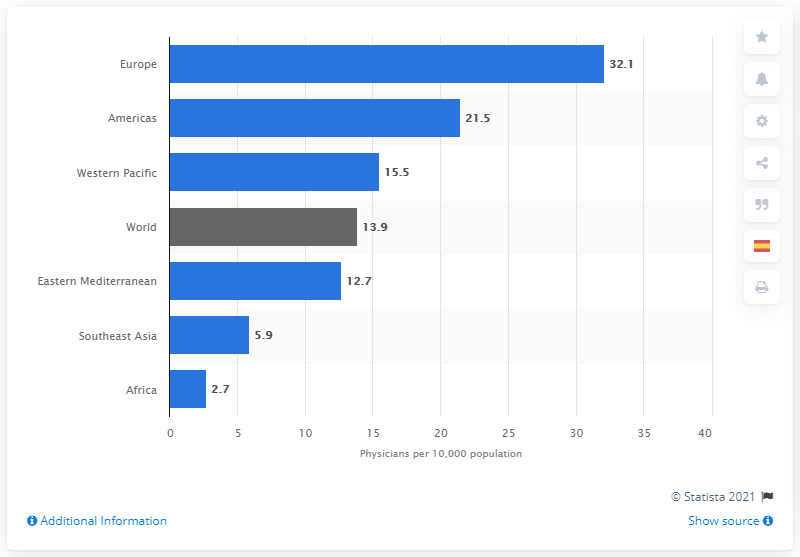Indicate a few pertinent items in this graphic. In 2013, the average density of physicians per 10,000 inhabitants in Southeast Asia was 5.9. 